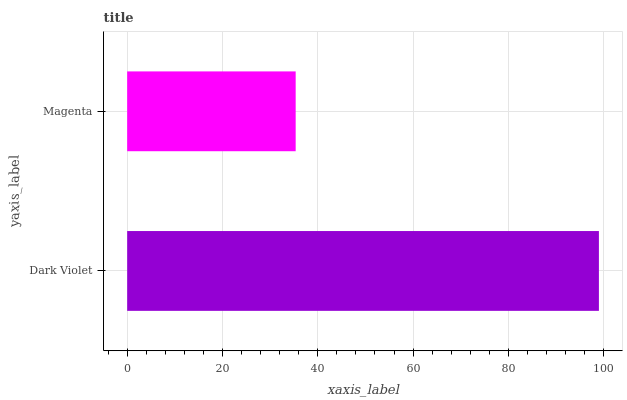Is Magenta the minimum?
Answer yes or no. Yes. Is Dark Violet the maximum?
Answer yes or no. Yes. Is Magenta the maximum?
Answer yes or no. No. Is Dark Violet greater than Magenta?
Answer yes or no. Yes. Is Magenta less than Dark Violet?
Answer yes or no. Yes. Is Magenta greater than Dark Violet?
Answer yes or no. No. Is Dark Violet less than Magenta?
Answer yes or no. No. Is Dark Violet the high median?
Answer yes or no. Yes. Is Magenta the low median?
Answer yes or no. Yes. Is Magenta the high median?
Answer yes or no. No. Is Dark Violet the low median?
Answer yes or no. No. 